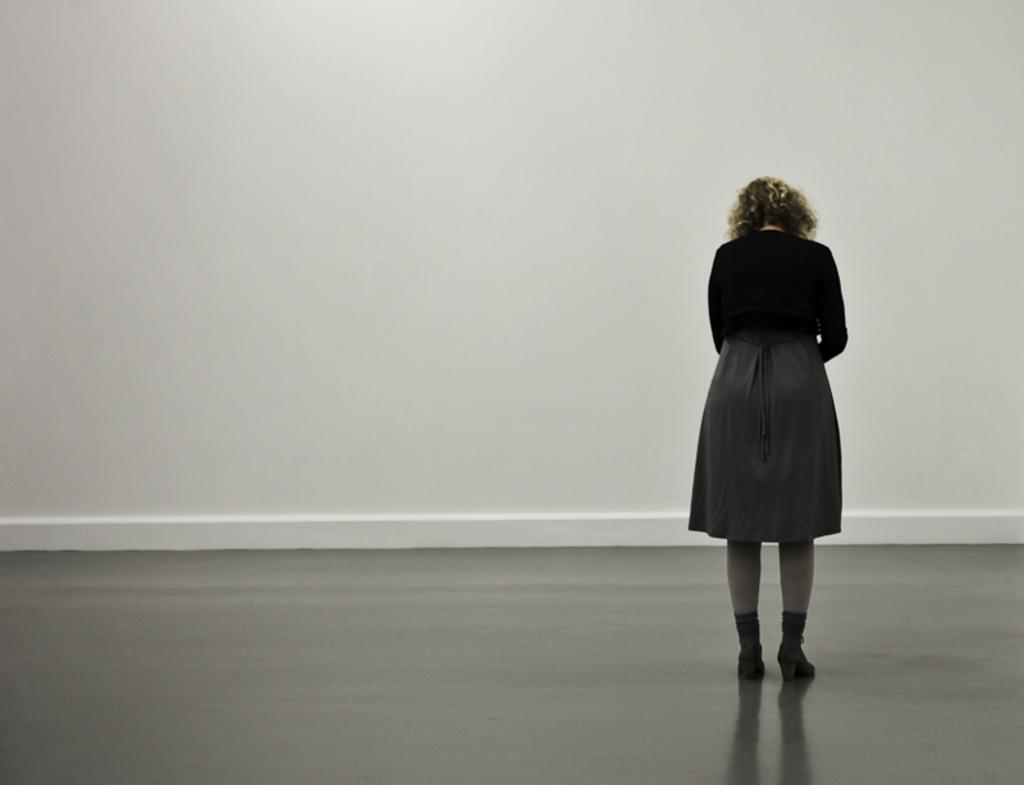Who is present in the image? There is a woman in the image. What is the woman doing in the image? The woman is standing on the floor. What can be seen in the background of the image? There is a white color wall in the background of the image. What type of whistle is the woman using in the image? There is no whistle present in the image. What agreement did the woman make with the person in the image? There is no indication of an agreement or another person in the image. 